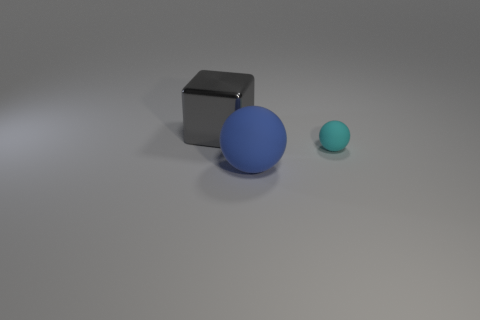Can you describe the lighting and texture of the objects in this image? The lighting in the image is diffused, casting soft shadows on the ground. The objects exhibit different textures; the small gray cube has a reflective metallic surface, while the spheres have a matte finish with the larger sphere being blue and the tiny one being cyan. 